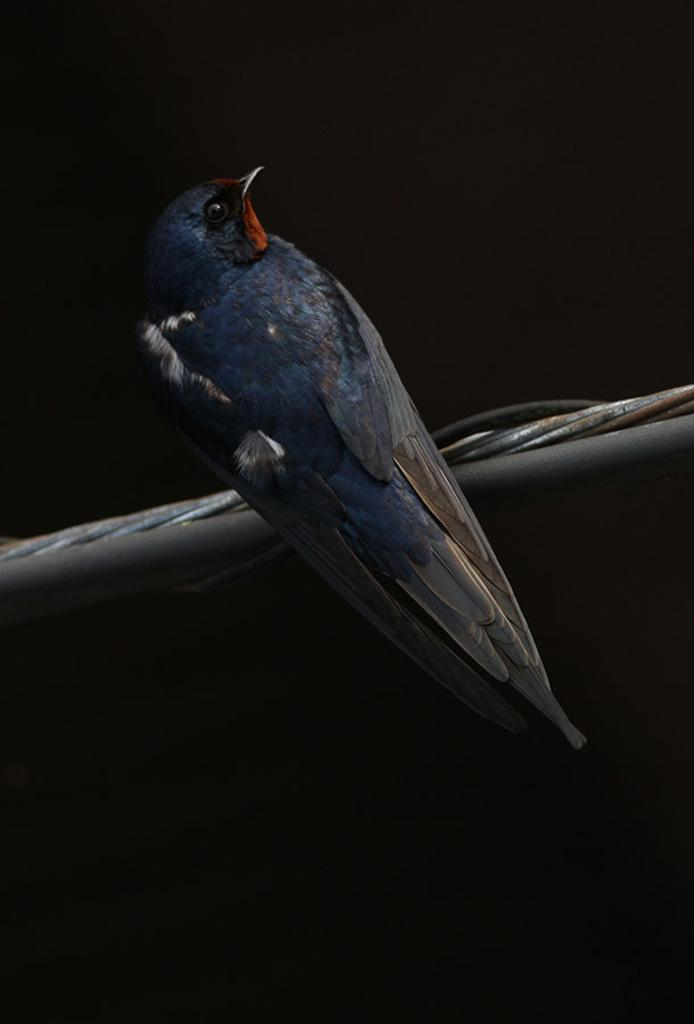What is the main subject of the image? There is a bird in the center of the image. What is the bird standing on? The bird appears to be standing on a black object. Can you describe the background of the image? The background of the image is very dark. How many tomatoes can be seen hanging from the wire in the image? There is no wire or tomatoes present in the image; it features a bird standing on a black object with a dark background. 